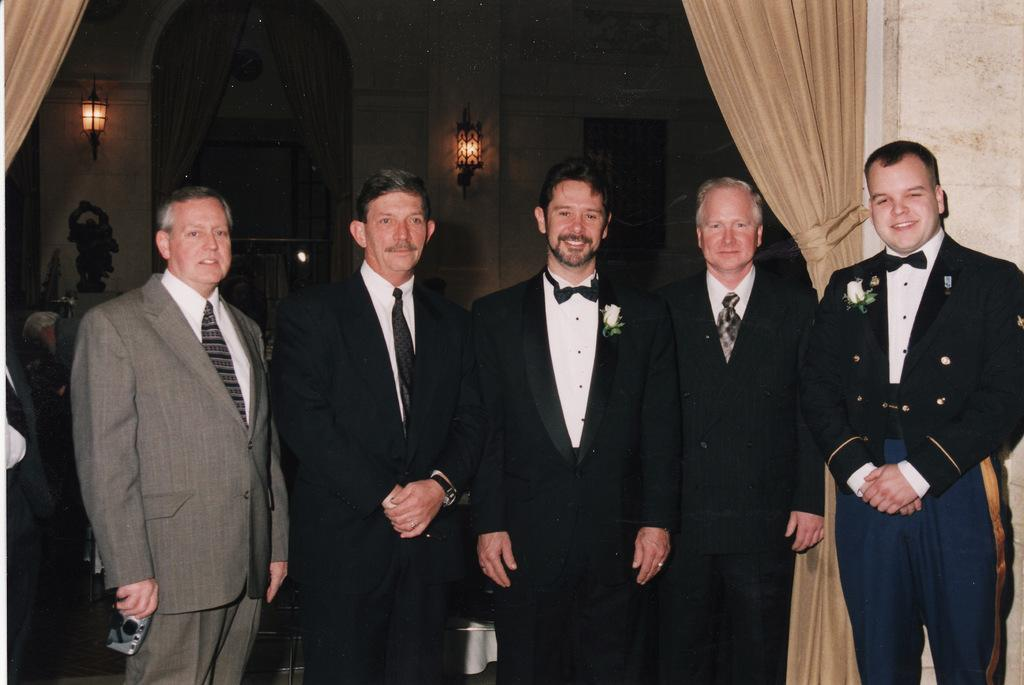How many people are in the image? There is a group of people in the image, but the exact number is not specified. What are the people doing in the image? The people are on the ground, but their specific activity is not mentioned. What can be seen in the background of the image? There is a wall and curtains in the background of the image. What type of crime is being committed in the image? There is no indication of any crime being committed in the image. The people are simply on the ground, and there is no context provided to suggest any criminal activity. 